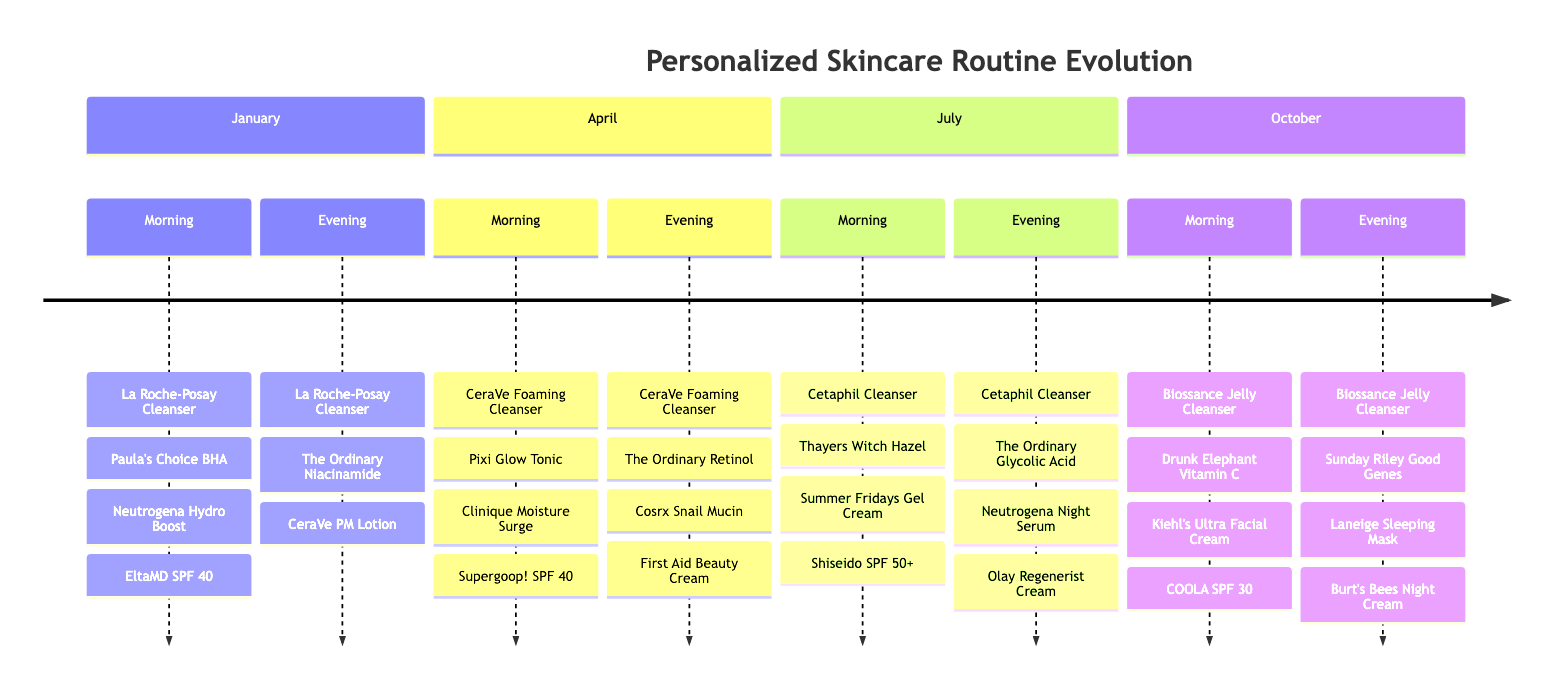What is the first product listed in the morning routine for January? The morning routine for January includes four products. The first product listed is "La Roche-Posay Toleriane Hydrating Gentle Cleanser."
Answer: La Roche-Posay Toleriane Hydrating Gentle Cleanser How many products are used in the evening routine for April? There are four products listed in the evening routine for April. The products are "CeraVe Foaming Facial Cleanser," "The Ordinary Retinol 0.5% in Squalane," "Cosrx Advanced Snail 96 Mucin Power Essence," and "First Aid Beauty Ultra Repair Cream."
Answer: 4 Which month features the product "Summer Fridays Cloud Dew Oil-Free Gel Cream" in the morning routine? The "Summer Fridays Cloud Dew Oil-Free Gel Cream" is listed in the morning routine for July. It is one of the four products used that month.
Answer: July In what month does the "Sunday Riley Good Genes All-In-One Lactic Acid Treatment" appear in the evening routine? The "Sunday Riley Good Genes All-In-One Lactic Acid Treatment" appears in the evening routine for October. It is one of the four products used during that month.
Answer: October Which month has a morning routine that includes "Clinique Moisture Surge 72-Hour Auto-Replenishing Hydrator"? The morning routine including "Clinique Moisture Surge 72-Hour Auto-Replenishing Hydrator" is for April. It is the third product in the lineup for that month.
Answer: April What is the last product in the evening routine for October? The last product listed in the evening routine for October is "Burt's Bees Intense Hydration Night Cream with Clary Sage." It is the fourth product in the evening lineup.
Answer: Burt's Bees Intense Hydration Night Cream with Clary Sage How many distinct months have a morning routine using SPF products? The months with morning routines that include SPF products are January (EltaMD UV Daily Broad-Spectrum SPF 40), April (Supergoop! Unseen Sunscreen SPF 40), July (Shiseido Ultimate Sun Protector Lotion SPF 50+), and October (COOLA Mineral Face Matte Finish Sunscreen SPF 30). This totals four months.
Answer: 4 Which evening routine uses "The Ordinary Glycolic Acid 7% Toning Solution"? The "The Ordinary Glycolic Acid 7% Toning Solution" is used in the evening routine for July. It is the second product in the evening lineup for that month.
Answer: July During which month did the skincare routine switch from La Roche-Posay products to CeraVe products in the morning? The switch from La Roche-Posay products to CeraVe products in the morning occurred in April. In January, La Roche-Posay products were used, and in April, the morning product starts with "CeraVe Foaming Facial Cleanser."
Answer: April 